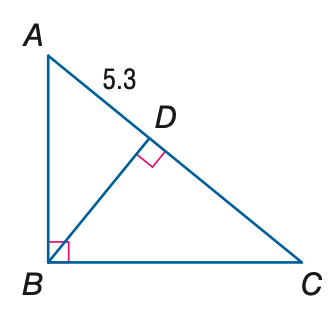Question: The orthocenter of \triangle A B C is located 6.4 units from point D. Find B C.
Choices:
A. 4.33
B. 6.40
C. 10.03
D. 20.25
Answer with the letter. Answer: C 